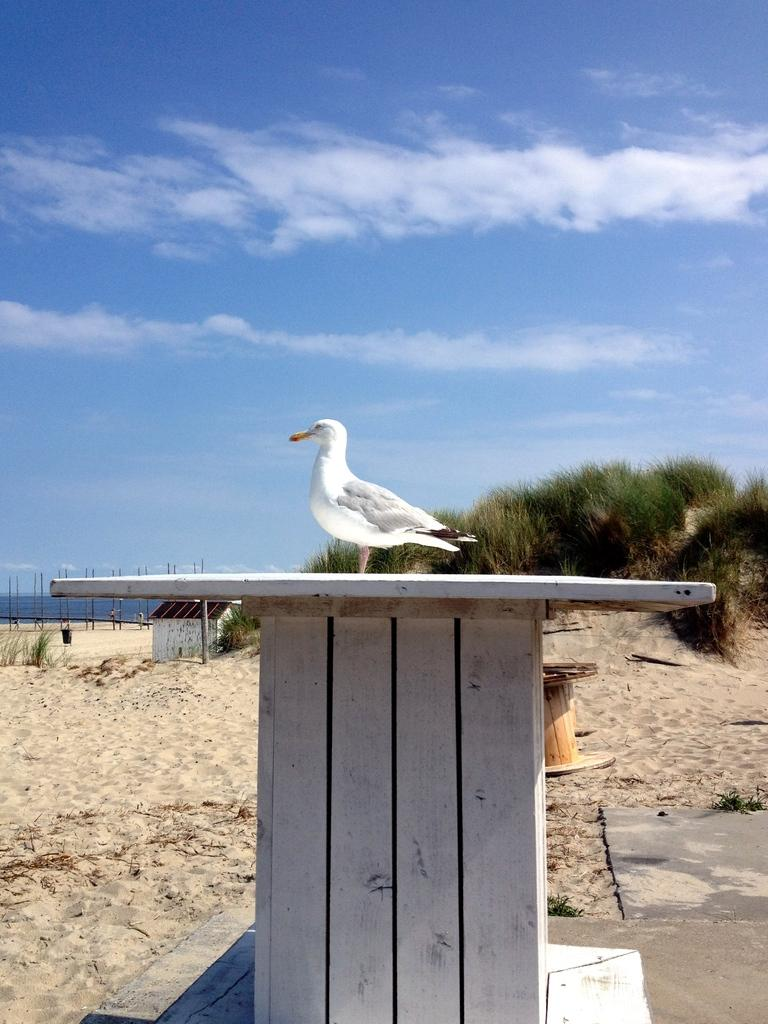What type of animal can be seen in the image? There is a bird in the image. What color is the bird? The bird is white in color. What material is the wooden object made of? The wooden object is made of wood. What type of terrain is visible in the image? Sand and grass are visible in the image. What type of structure can be seen in the image? There is a building in the image. How would you describe the sky in the image? The sky is cloudy and pale blue in color. What type of respect can be seen in the image? There is no indication of respect in the image; it features a bird, a wooden object, sand, grass, a building, and a cloudy sky. What type of plate is being used by the scarecrow in the image? There is no scarecrow or plate present in the image. 